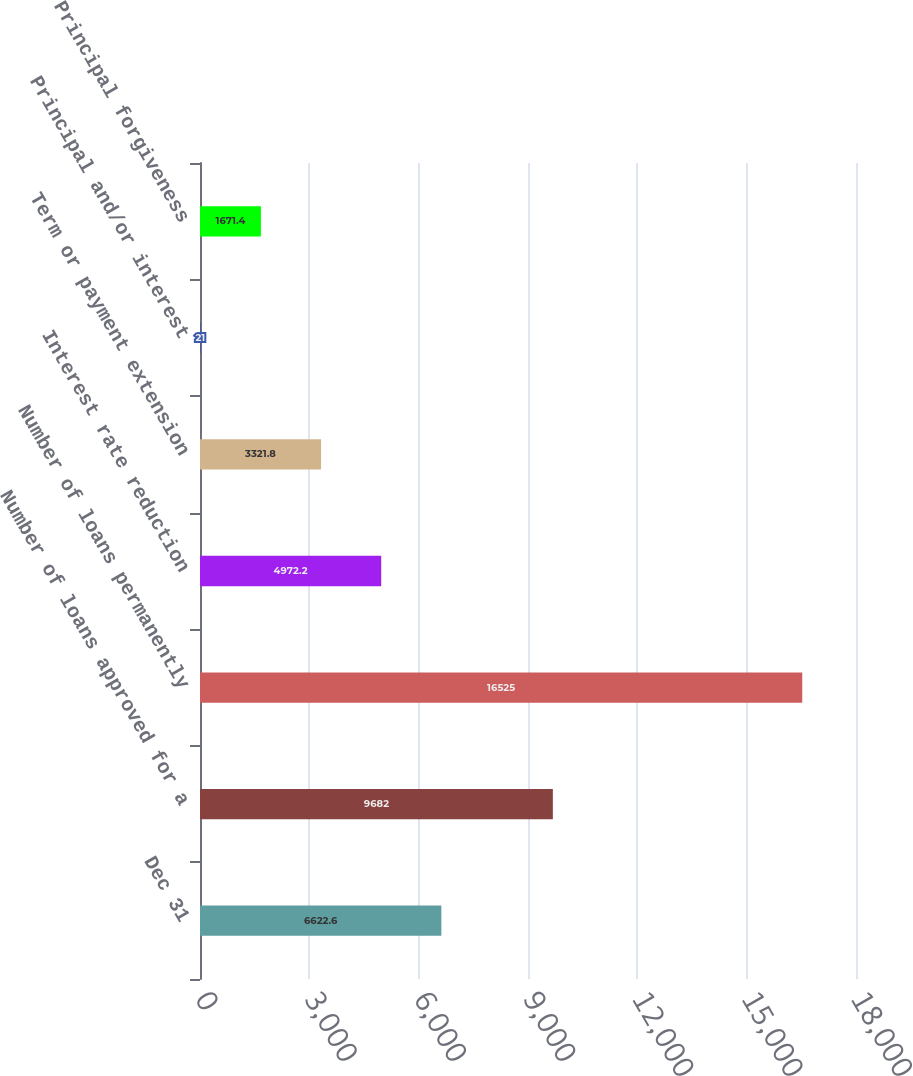Convert chart. <chart><loc_0><loc_0><loc_500><loc_500><bar_chart><fcel>Dec 31<fcel>Number of loans approved for a<fcel>Number of loans permanently<fcel>Interest rate reduction<fcel>Term or payment extension<fcel>Principal and/or interest<fcel>Principal forgiveness<nl><fcel>6622.6<fcel>9682<fcel>16525<fcel>4972.2<fcel>3321.8<fcel>21<fcel>1671.4<nl></chart> 